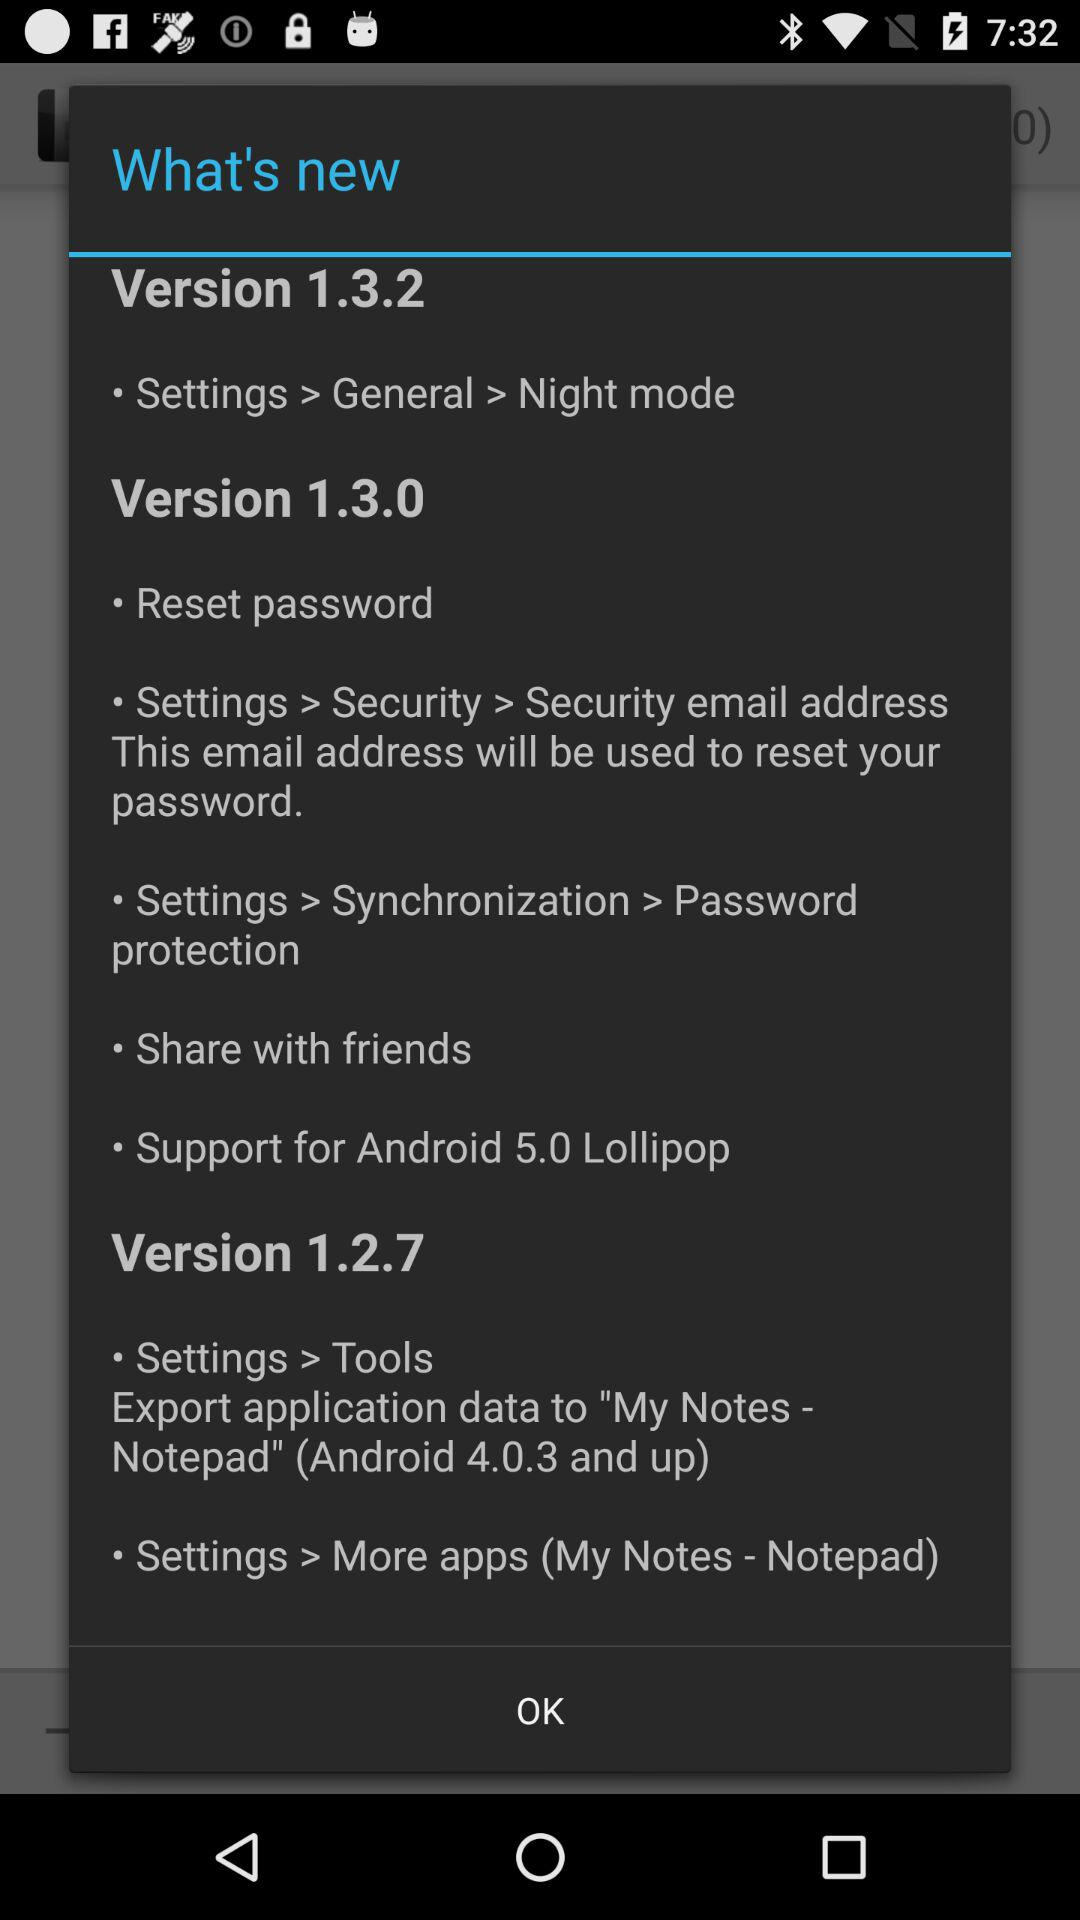In which version is "Android 4.0.3 and up" mentioned? It is mentioned in version 1.2.7. 